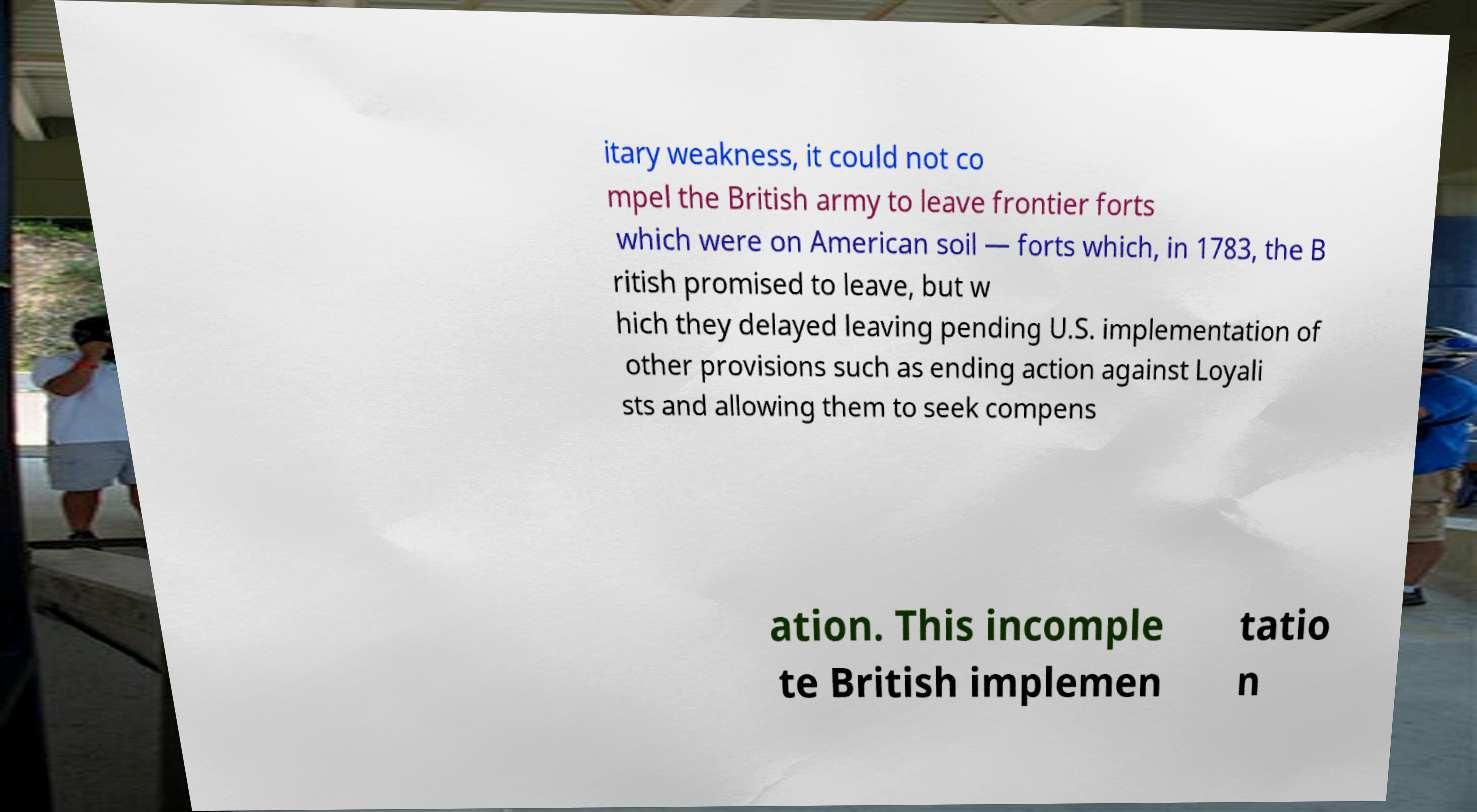For documentation purposes, I need the text within this image transcribed. Could you provide that? itary weakness, it could not co mpel the British army to leave frontier forts which were on American soil — forts which, in 1783, the B ritish promised to leave, but w hich they delayed leaving pending U.S. implementation of other provisions such as ending action against Loyali sts and allowing them to seek compens ation. This incomple te British implemen tatio n 